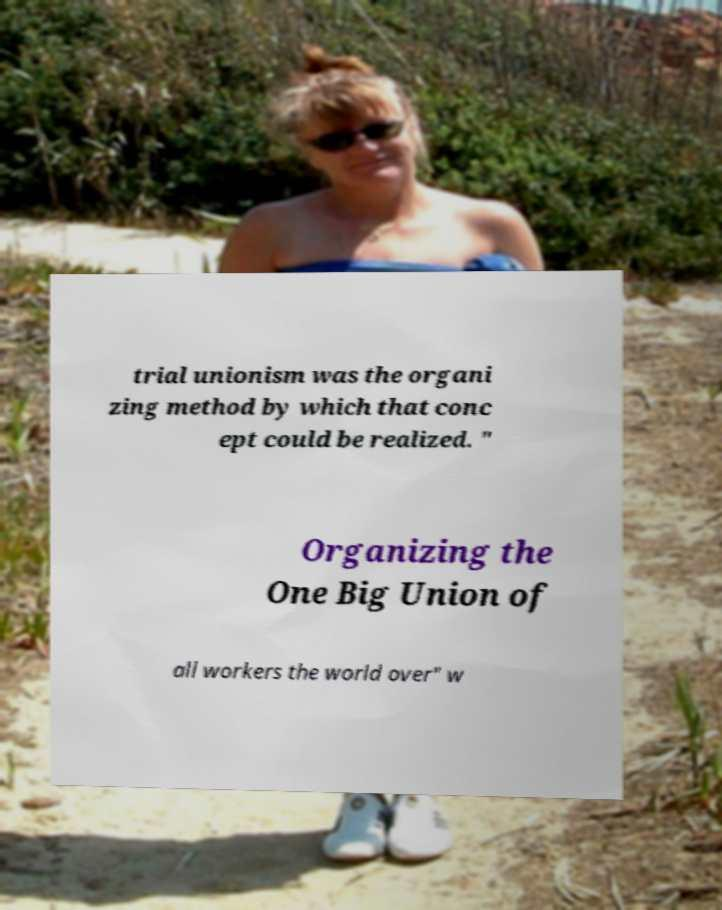What messages or text are displayed in this image? I need them in a readable, typed format. trial unionism was the organi zing method by which that conc ept could be realized. " Organizing the One Big Union of all workers the world over" w 